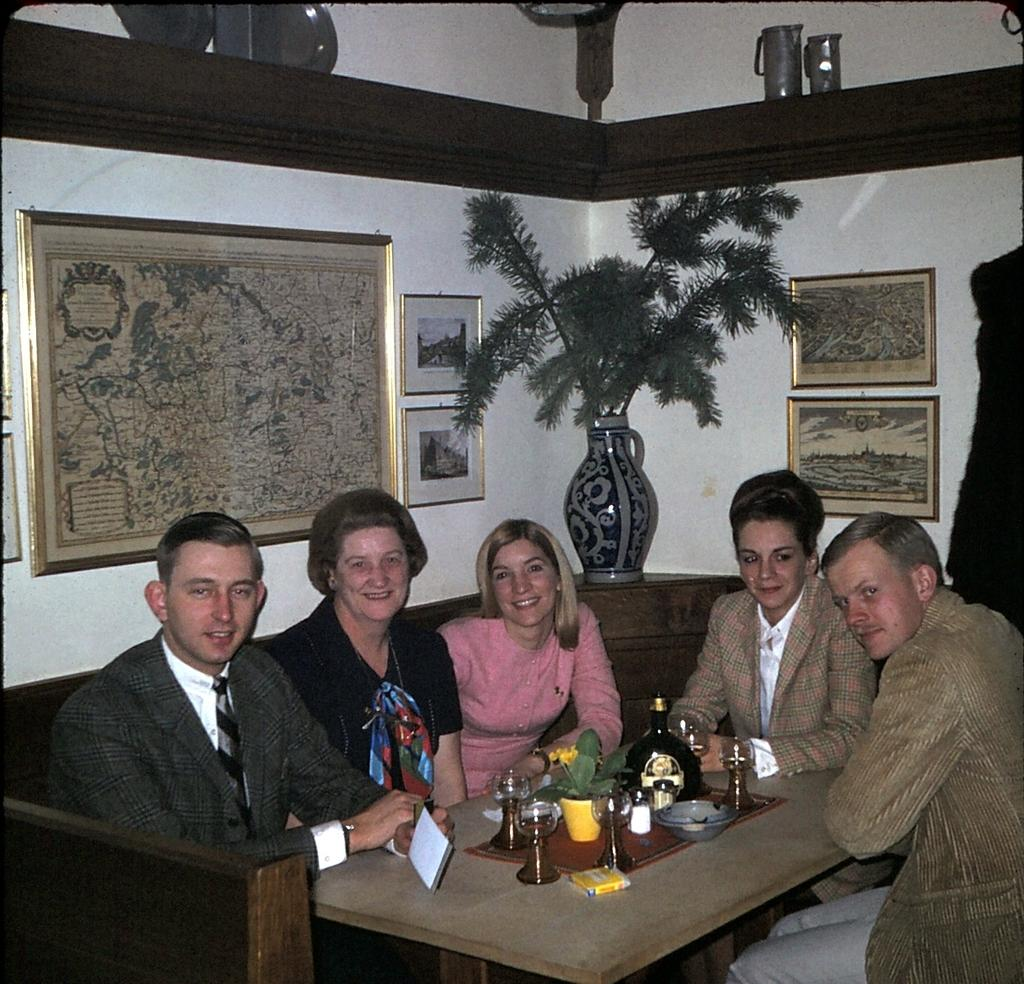What are the people in the image doing? There is a group of persons sitting on a sofa in the image. What is in front of the sofa? The sofa is in front of a table. What can be seen in the background of the image? There are photos and a flower vase in the background. What type of jeans is the oven wearing in the image? There is no oven or jeans present in the image. 